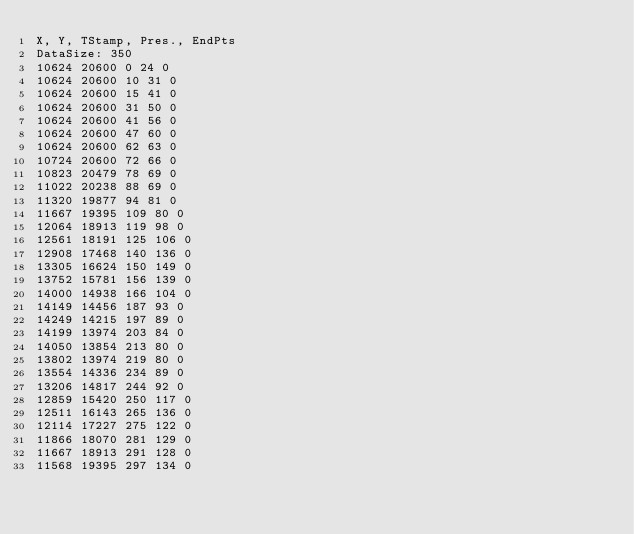<code> <loc_0><loc_0><loc_500><loc_500><_SML_>X, Y, TStamp, Pres., EndPts
DataSize: 350
10624 20600 0 24 0
10624 20600 10 31 0
10624 20600 15 41 0
10624 20600 31 50 0
10624 20600 41 56 0
10624 20600 47 60 0
10624 20600 62 63 0
10724 20600 72 66 0
10823 20479 78 69 0
11022 20238 88 69 0
11320 19877 94 81 0
11667 19395 109 80 0
12064 18913 119 98 0
12561 18191 125 106 0
12908 17468 140 136 0
13305 16624 150 149 0
13752 15781 156 139 0
14000 14938 166 104 0
14149 14456 187 93 0
14249 14215 197 89 0
14199 13974 203 84 0
14050 13854 213 80 0
13802 13974 219 80 0
13554 14336 234 89 0
13206 14817 244 92 0
12859 15420 250 117 0
12511 16143 265 136 0
12114 17227 275 122 0
11866 18070 281 129 0
11667 18913 291 128 0
11568 19395 297 134 0</code> 